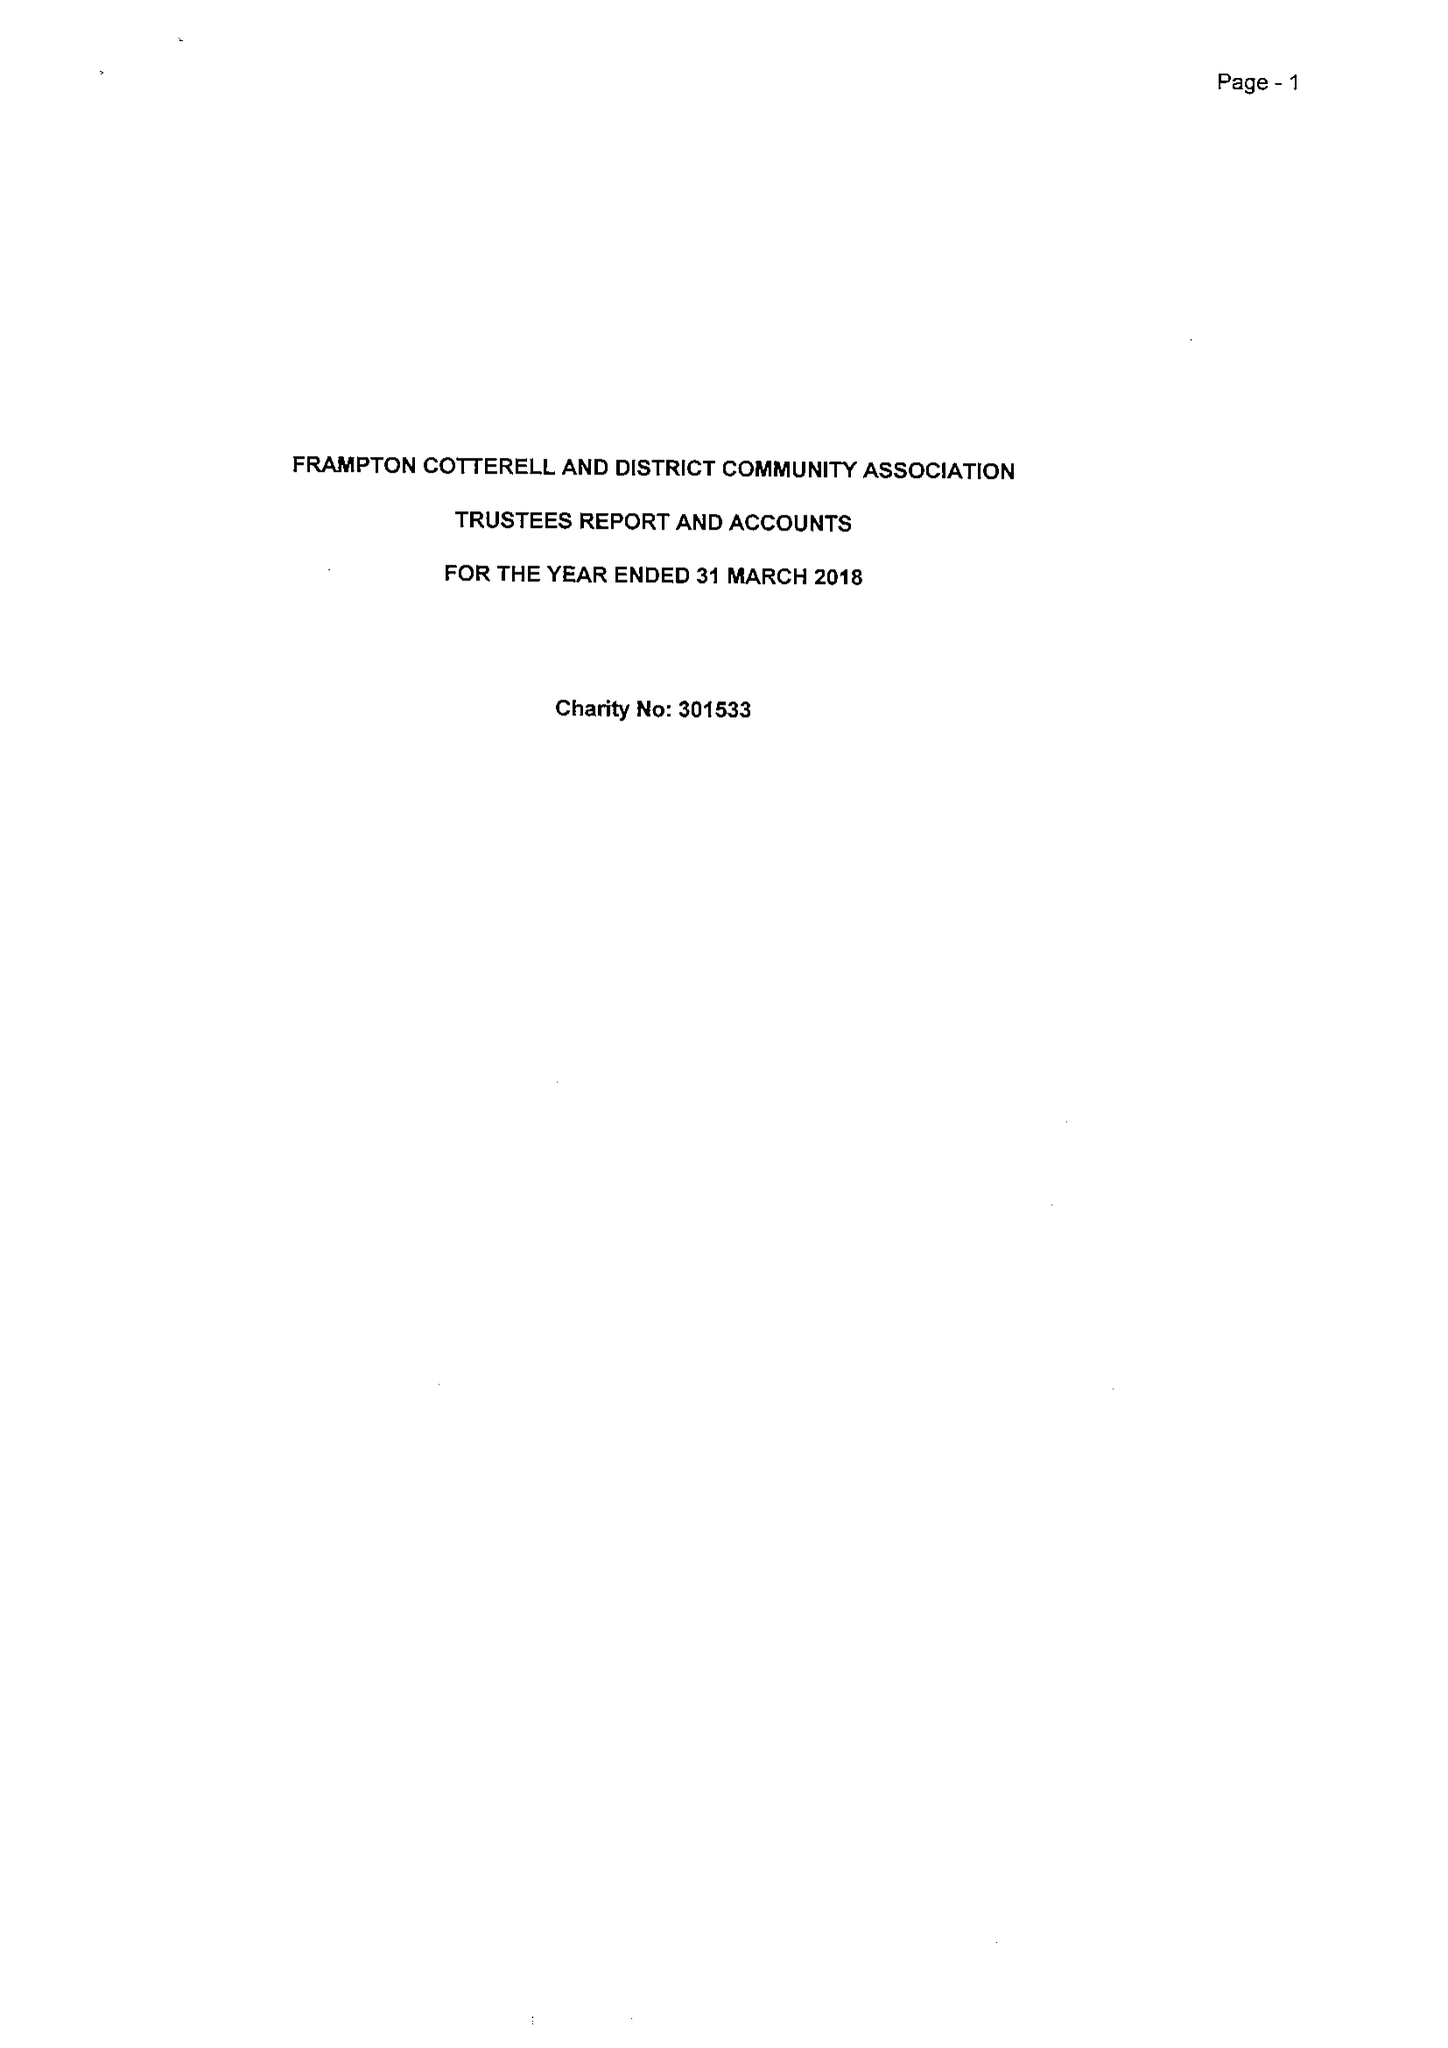What is the value for the address__post_town?
Answer the question using a single word or phrase. BRISTOL 